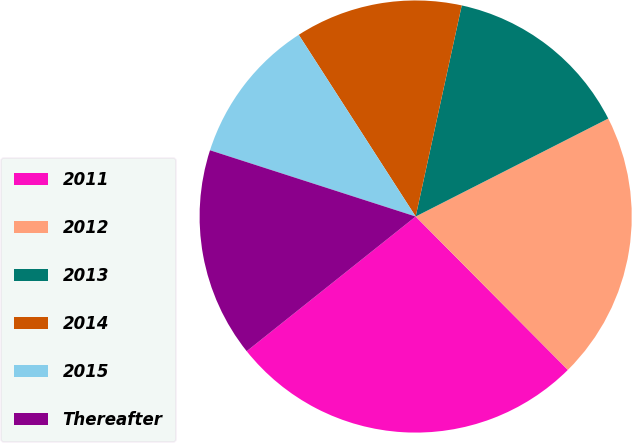Convert chart to OTSL. <chart><loc_0><loc_0><loc_500><loc_500><pie_chart><fcel>2011<fcel>2012<fcel>2013<fcel>2014<fcel>2015<fcel>Thereafter<nl><fcel>26.73%<fcel>20.05%<fcel>14.09%<fcel>12.52%<fcel>10.94%<fcel>15.67%<nl></chart> 